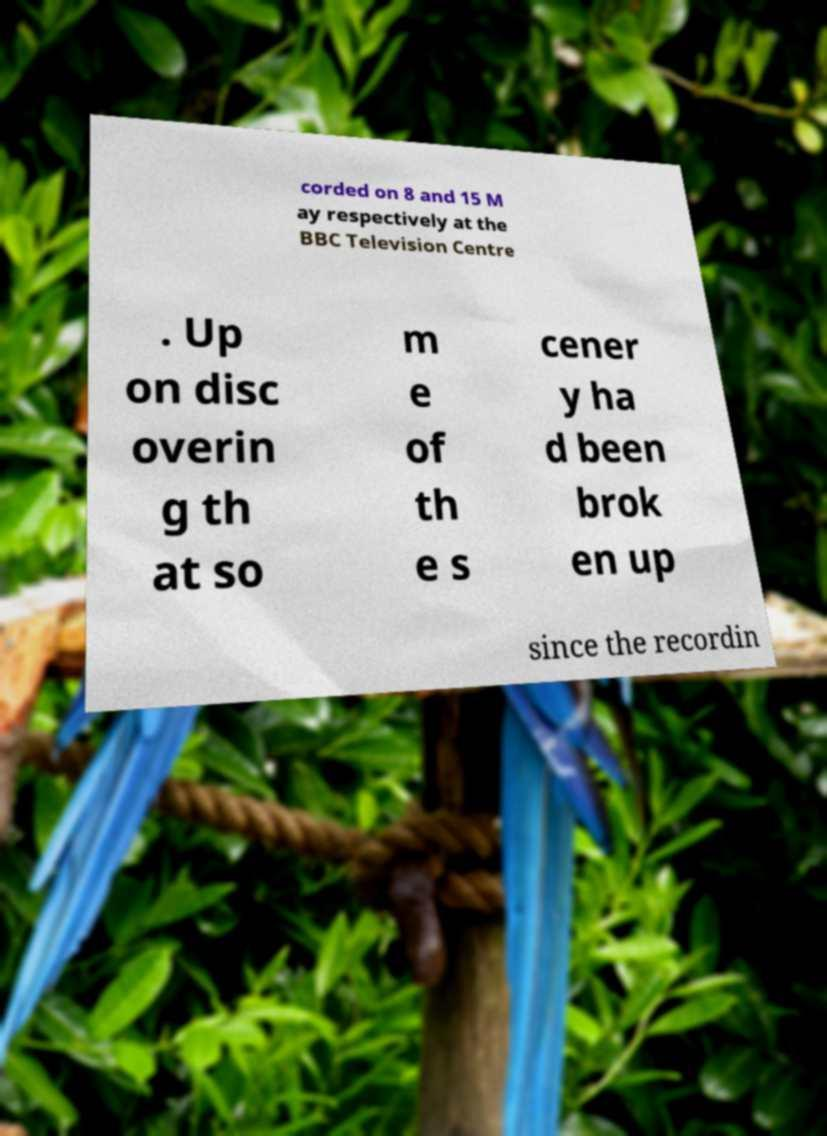For documentation purposes, I need the text within this image transcribed. Could you provide that? corded on 8 and 15 M ay respectively at the BBC Television Centre . Up on disc overin g th at so m e of th e s cener y ha d been brok en up since the recordin 